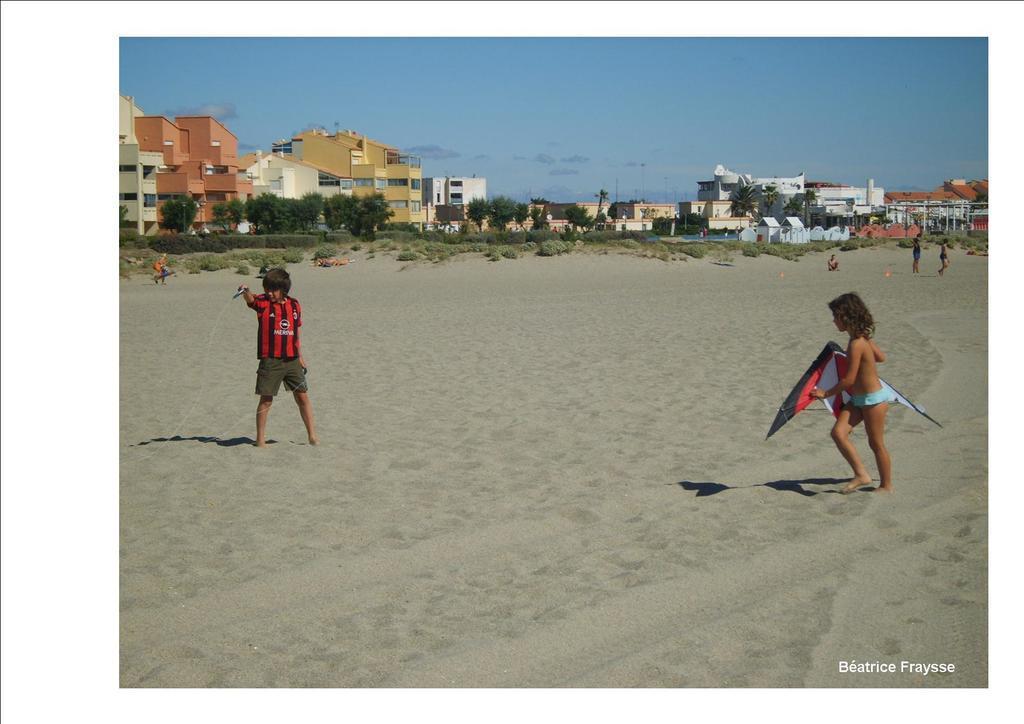How would you summarize this image in a sentence or two? In this picture there are children on the right and left side of the image, it seems to be they are flying kites in the image and there are poles, trees, and buildings in the background area of the image. 